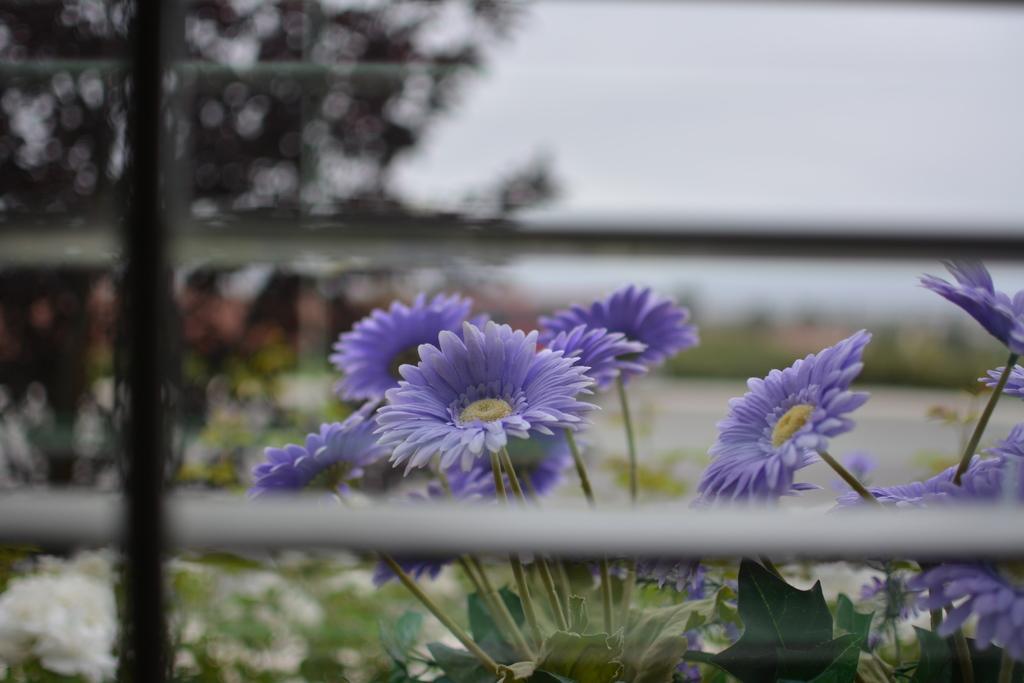Can you describe this image briefly? In this image I can see flowering plants, fence and the sky. This image is taken may be in a garden. 